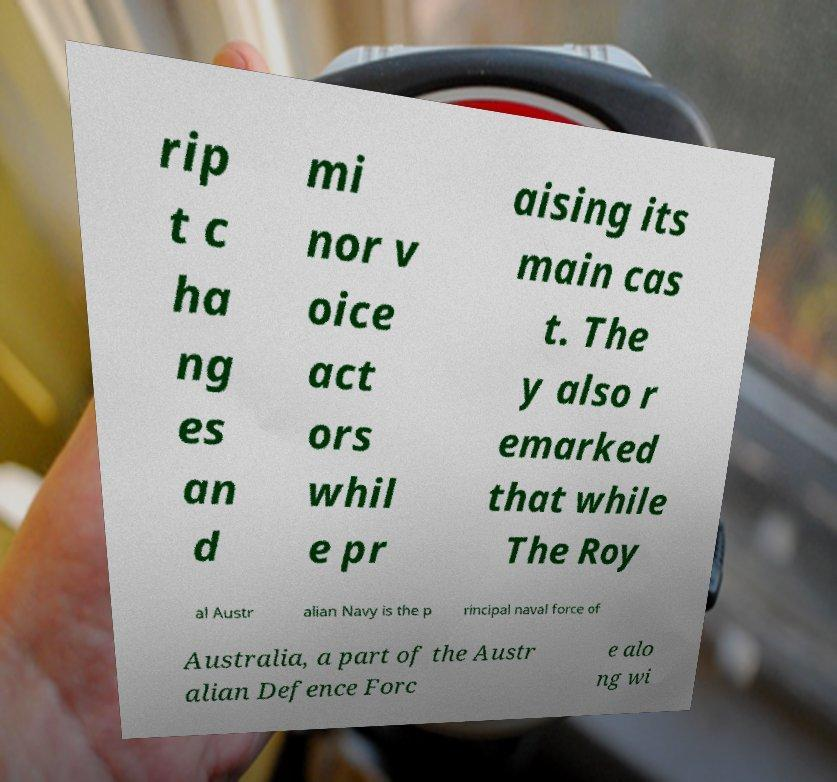There's text embedded in this image that I need extracted. Can you transcribe it verbatim? rip t c ha ng es an d mi nor v oice act ors whil e pr aising its main cas t. The y also r emarked that while The Roy al Austr alian Navy is the p rincipal naval force of Australia, a part of the Austr alian Defence Forc e alo ng wi 